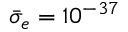<formula> <loc_0><loc_0><loc_500><loc_500>\bar { \sigma } _ { e } = 1 0 ^ { - 3 7 }</formula> 